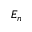Convert formula to latex. <formula><loc_0><loc_0><loc_500><loc_500>E _ { n }</formula> 